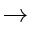<formula> <loc_0><loc_0><loc_500><loc_500>\rightarrow</formula> 